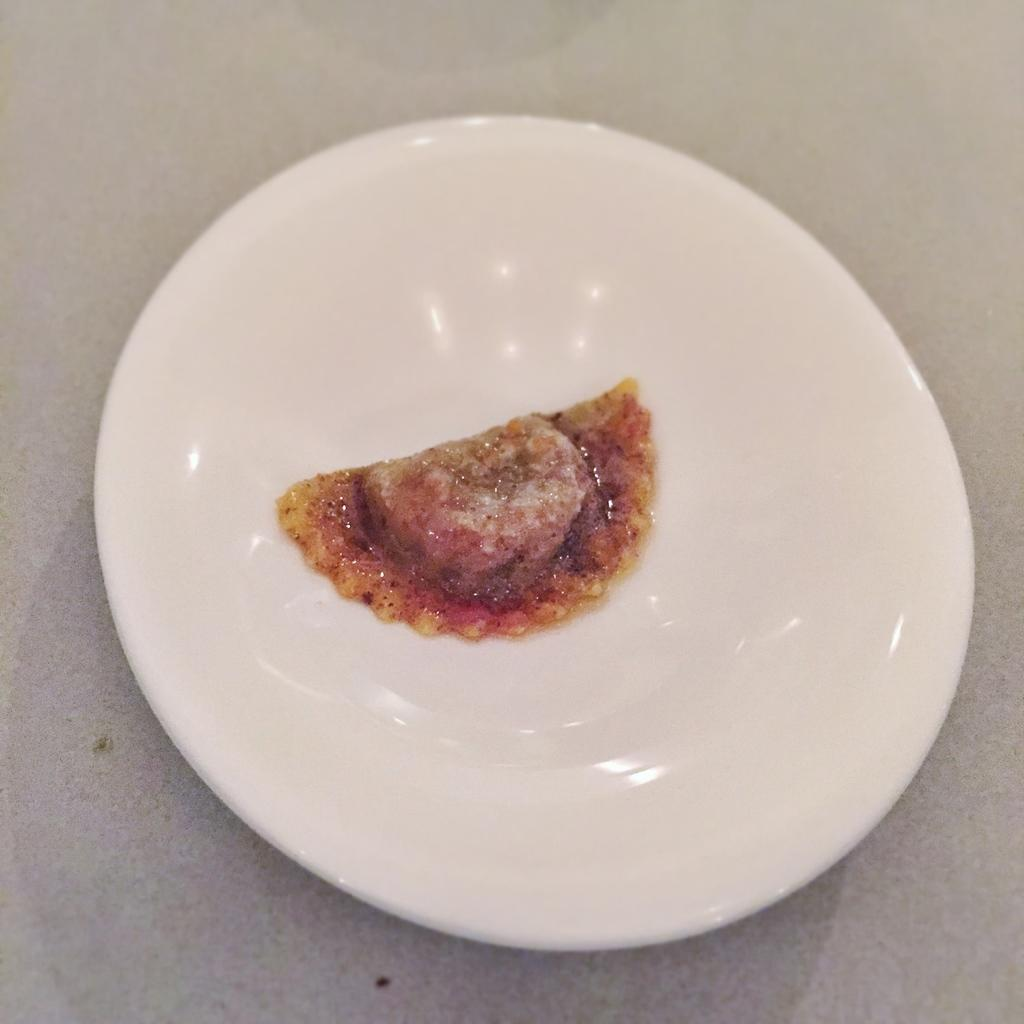What is located in the center of the image? There is a table in the center of the image. What is placed on the table? There is a plate on the table. What can be seen on the plate? There is a food item on the plate. What type of organization is depicted on the plate? There is no organization depicted on the plate; it contains a food item. 